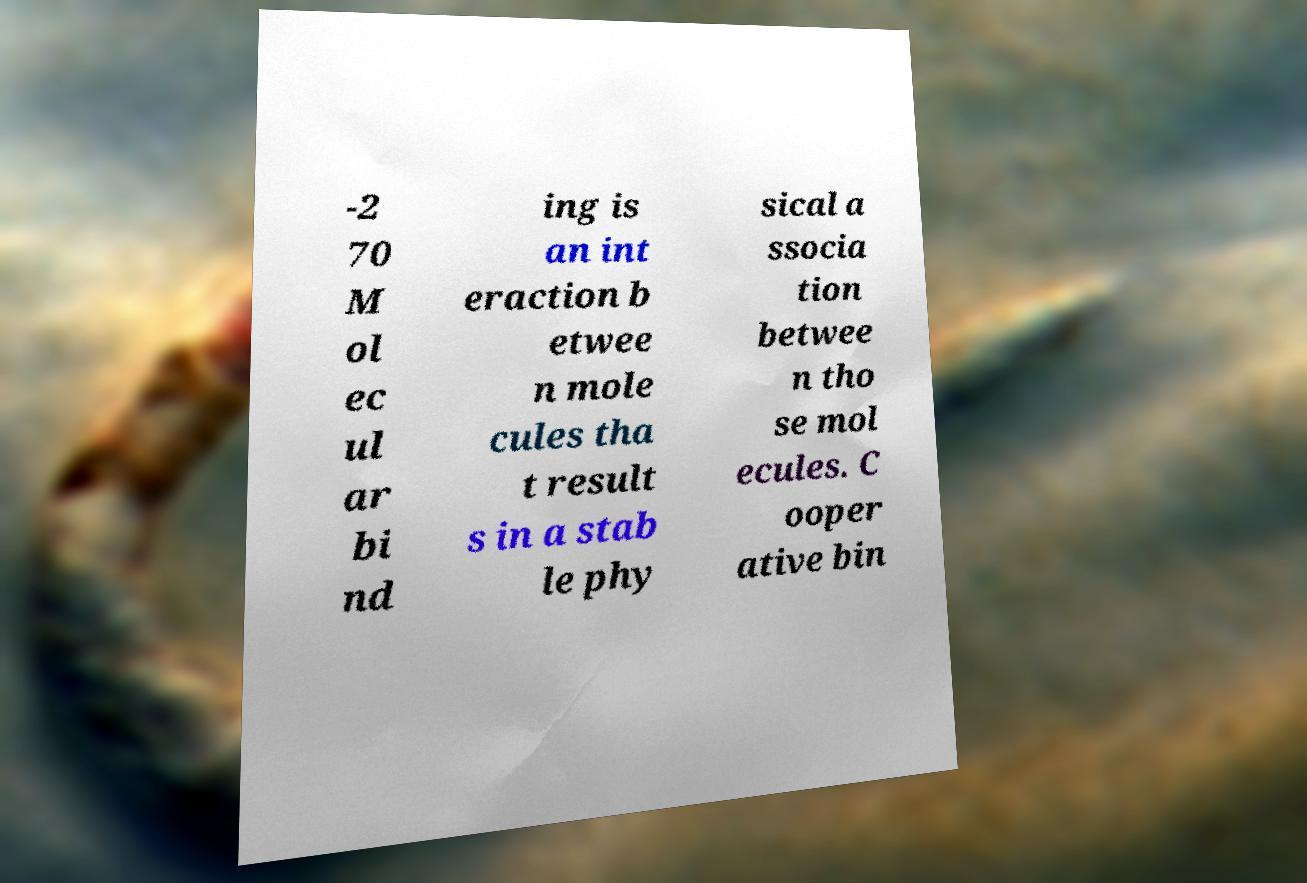What messages or text are displayed in this image? I need them in a readable, typed format. -2 70 M ol ec ul ar bi nd ing is an int eraction b etwee n mole cules tha t result s in a stab le phy sical a ssocia tion betwee n tho se mol ecules. C ooper ative bin 